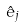<formula> <loc_0><loc_0><loc_500><loc_500>\hat { e } _ { j }</formula> 